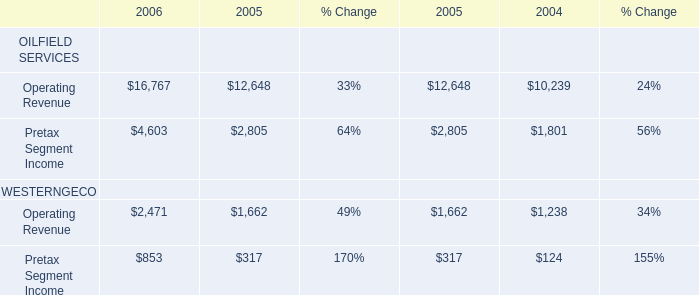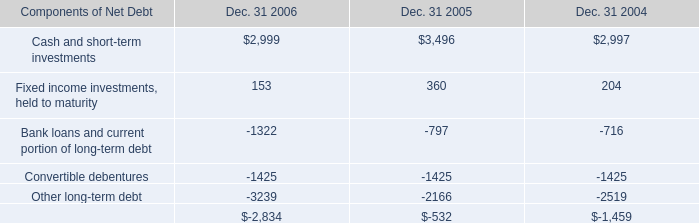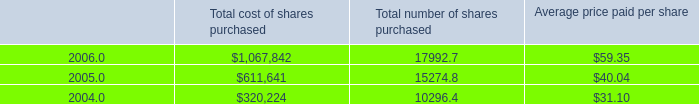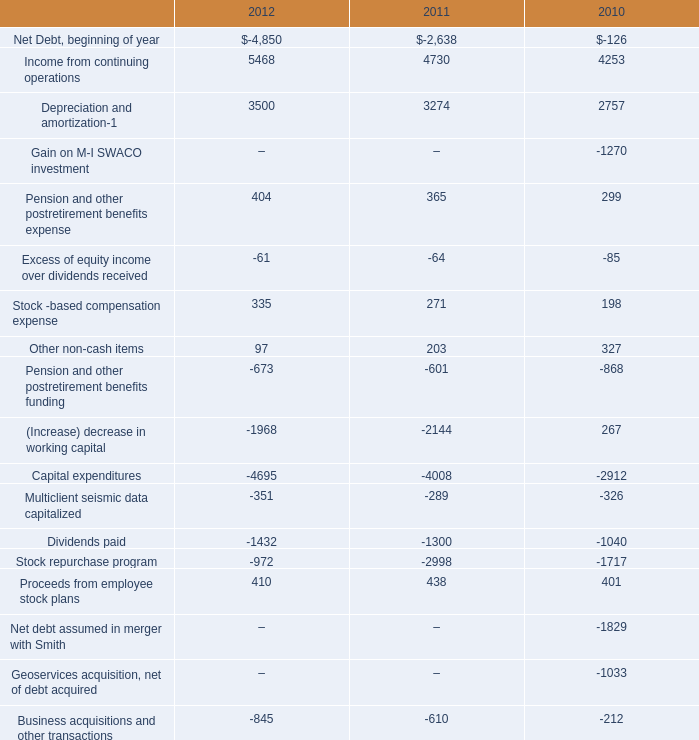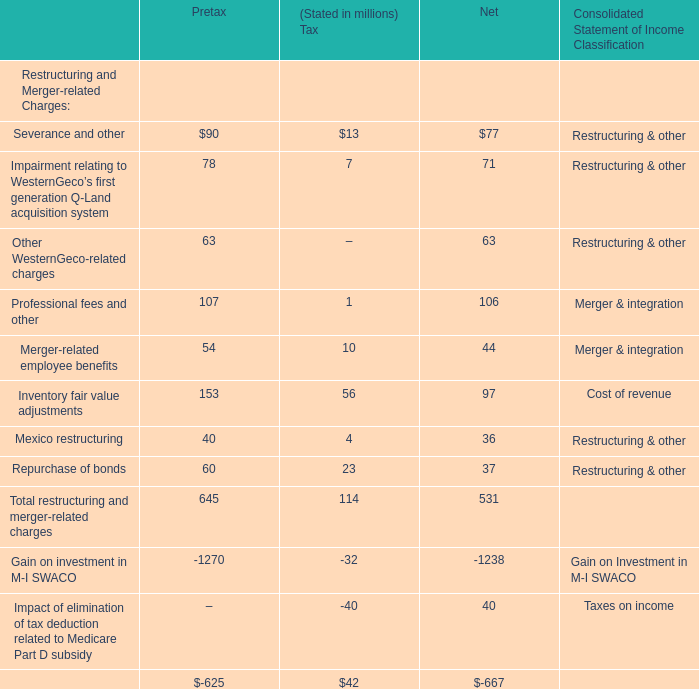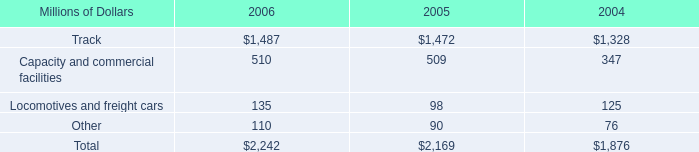How many kinds of Restructuring and Merger-related Charges is the Net Income larger than 100 million? 
Answer: 1. 